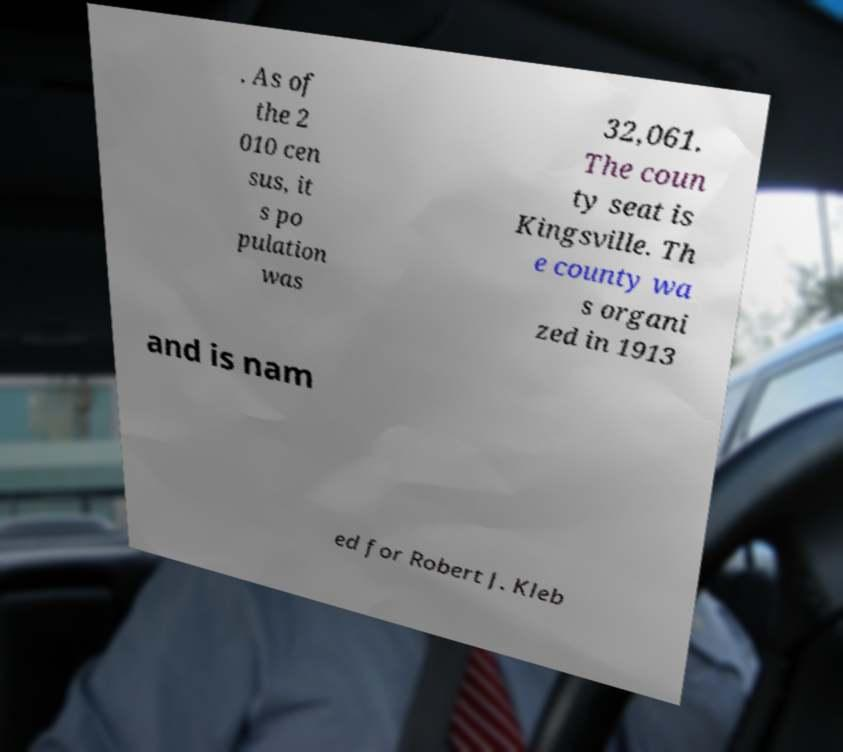For documentation purposes, I need the text within this image transcribed. Could you provide that? . As of the 2 010 cen sus, it s po pulation was 32,061. The coun ty seat is Kingsville. Th e county wa s organi zed in 1913 and is nam ed for Robert J. Kleb 